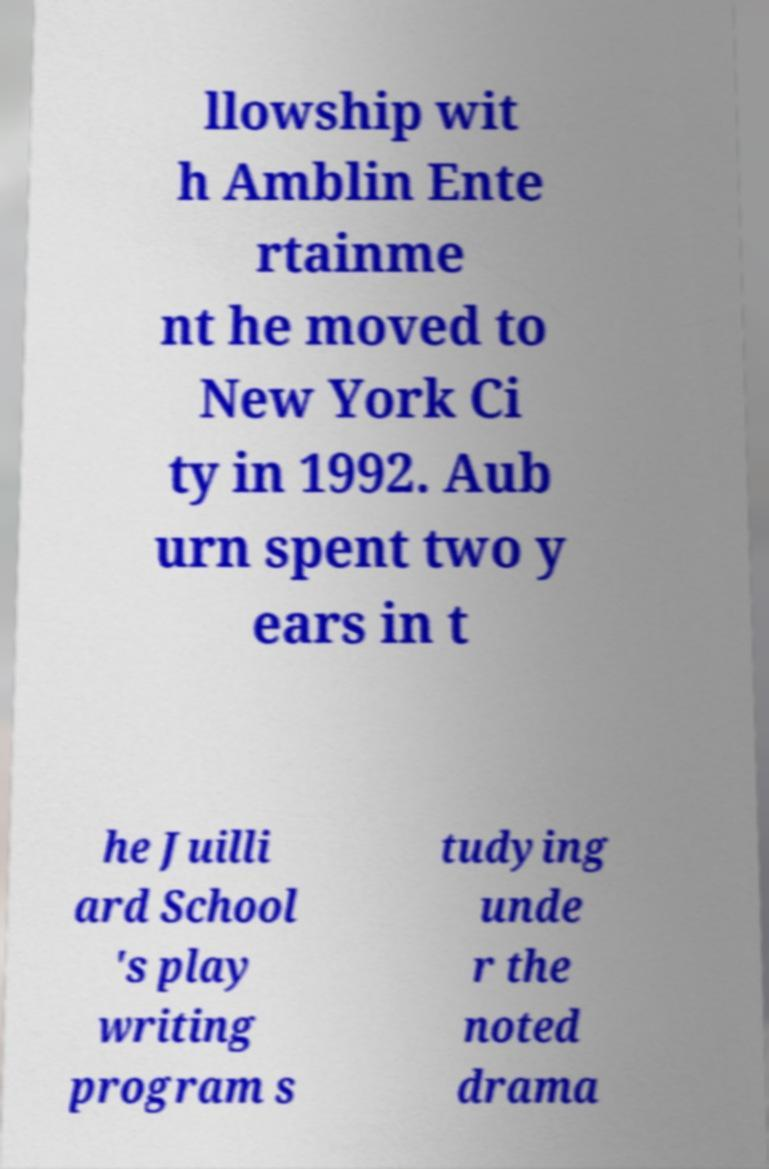Could you extract and type out the text from this image? llowship wit h Amblin Ente rtainme nt he moved to New York Ci ty in 1992. Aub urn spent two y ears in t he Juilli ard School 's play writing program s tudying unde r the noted drama 